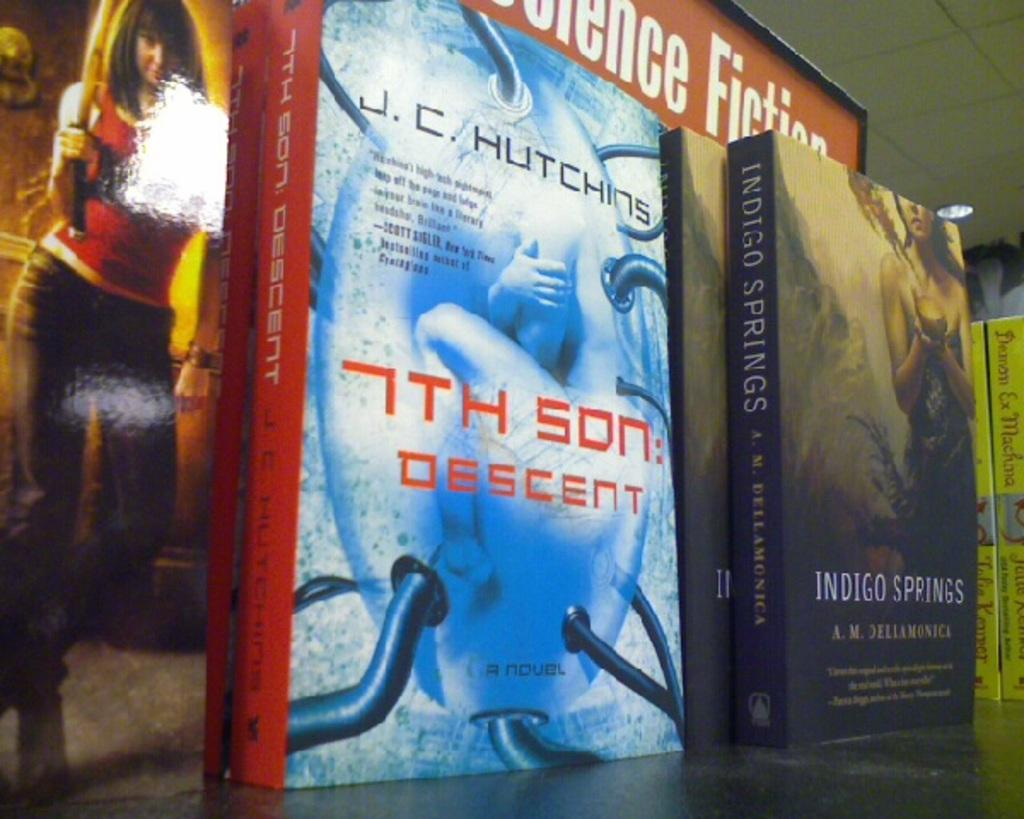<image>
Write a terse but informative summary of the picture. A few books lined up on a shelf with one called the 7th Son: Descent and the other one titled Indigo Springs. 